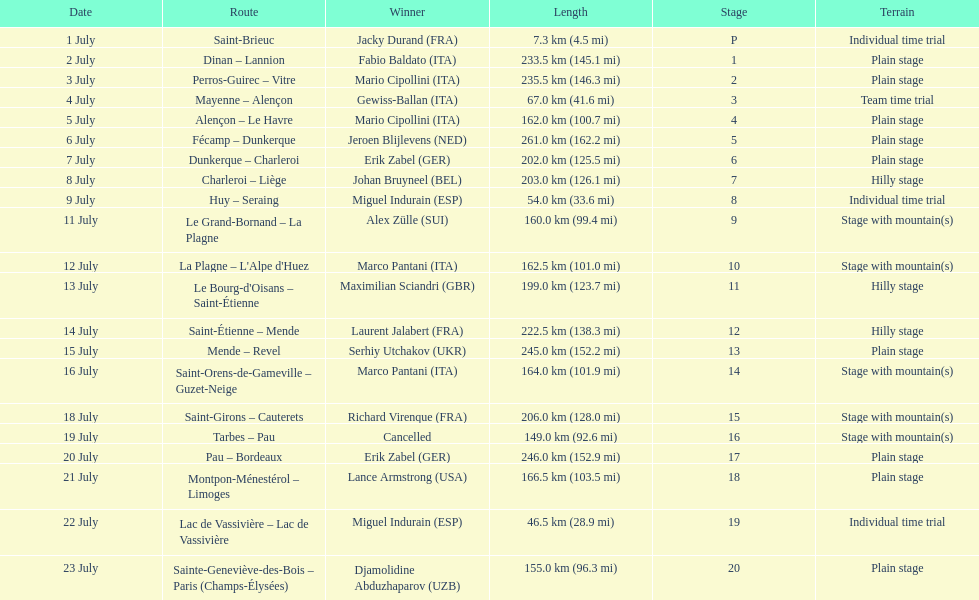What were the lengths of all the stages of the 1995 tour de france? 7.3 km (4.5 mi), 233.5 km (145.1 mi), 235.5 km (146.3 mi), 67.0 km (41.6 mi), 162.0 km (100.7 mi), 261.0 km (162.2 mi), 202.0 km (125.5 mi), 203.0 km (126.1 mi), 54.0 km (33.6 mi), 160.0 km (99.4 mi), 162.5 km (101.0 mi), 199.0 km (123.7 mi), 222.5 km (138.3 mi), 245.0 km (152.2 mi), 164.0 km (101.9 mi), 206.0 km (128.0 mi), 149.0 km (92.6 mi), 246.0 km (152.9 mi), 166.5 km (103.5 mi), 46.5 km (28.9 mi), 155.0 km (96.3 mi). Of those, which one occurred on july 8th? 203.0 km (126.1 mi). 